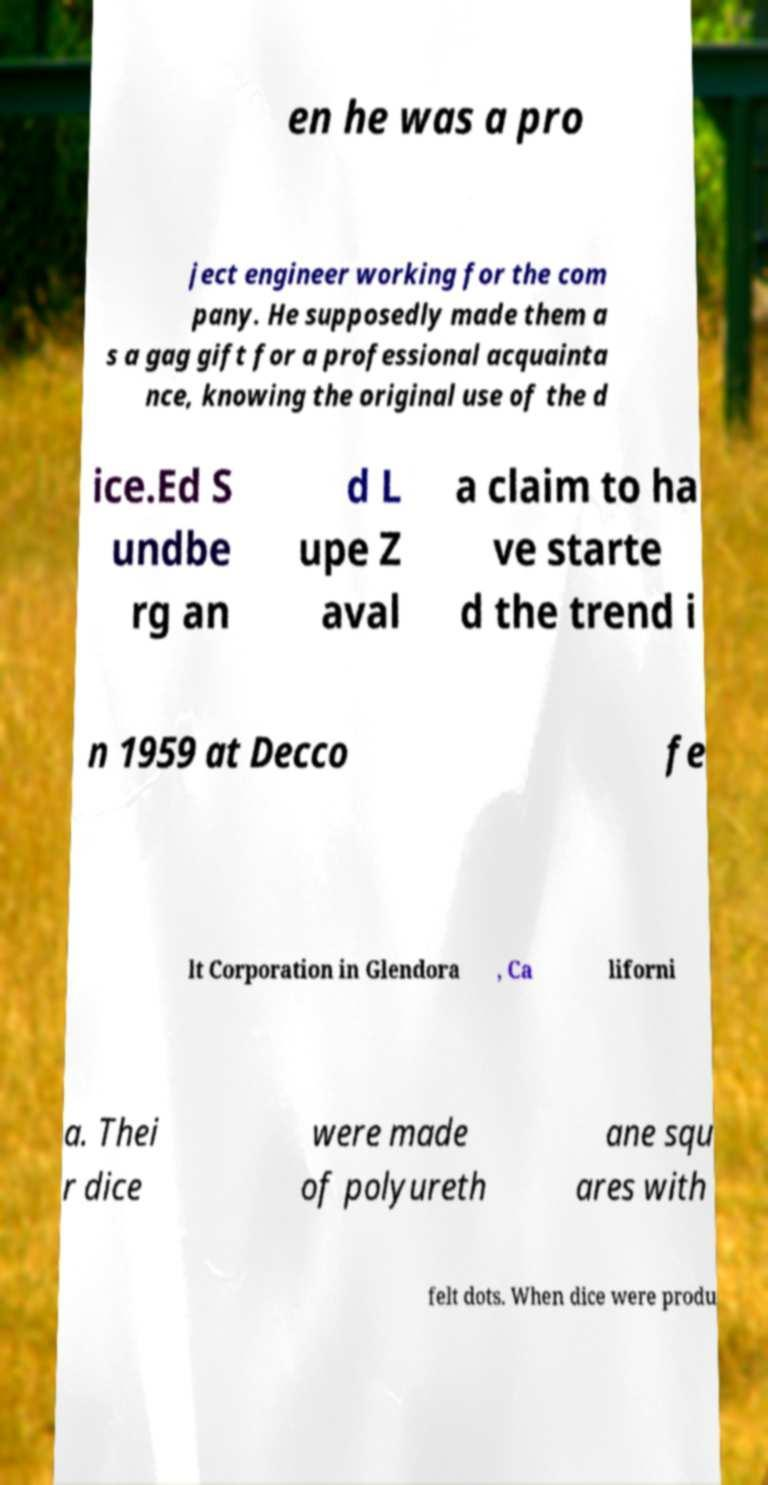Can you accurately transcribe the text from the provided image for me? en he was a pro ject engineer working for the com pany. He supposedly made them a s a gag gift for a professional acquainta nce, knowing the original use of the d ice.Ed S undbe rg an d L upe Z aval a claim to ha ve starte d the trend i n 1959 at Decco fe lt Corporation in Glendora , Ca liforni a. Thei r dice were made of polyureth ane squ ares with felt dots. When dice were produ 